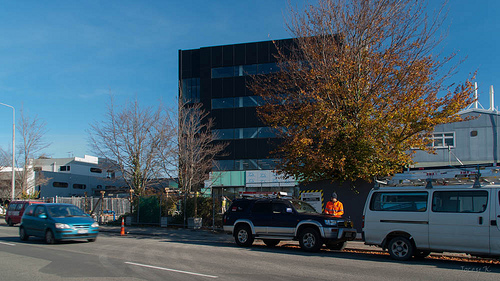<image>
Is the building behind the tree? Yes. From this viewpoint, the building is positioned behind the tree, with the tree partially or fully occluding the building. 